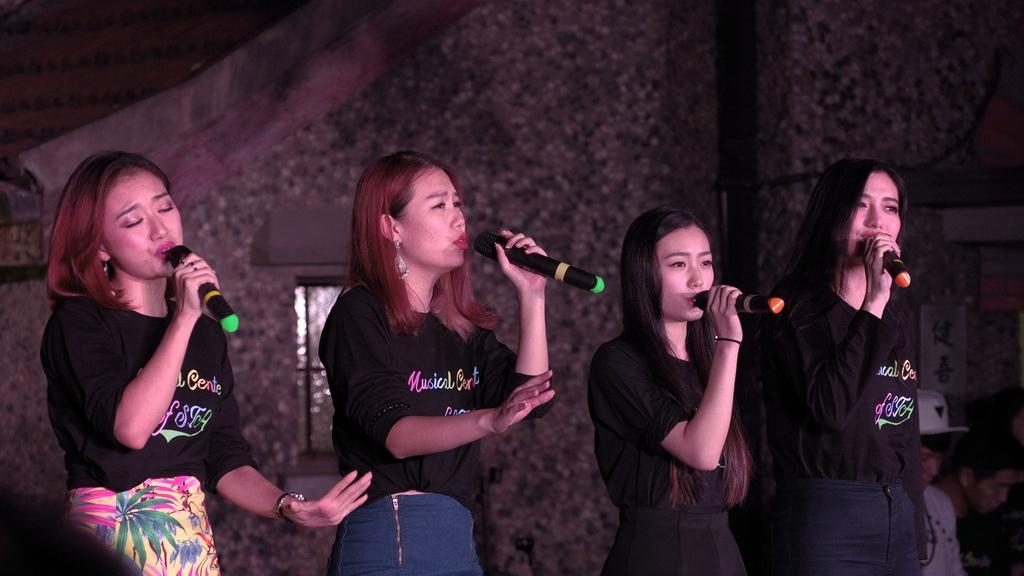How many people are in the image? There are four women in the image. What are the women doing in the image? The women are singing. What objects are the women holding in their hands? Each woman is holding a microphone in her hand. What type of country can be seen in the background of the image? There is no country visible in the background of the image; it only shows the four women singing with microphones. How many balloons are floating above the women in the image? There are no balloons present in the image. 